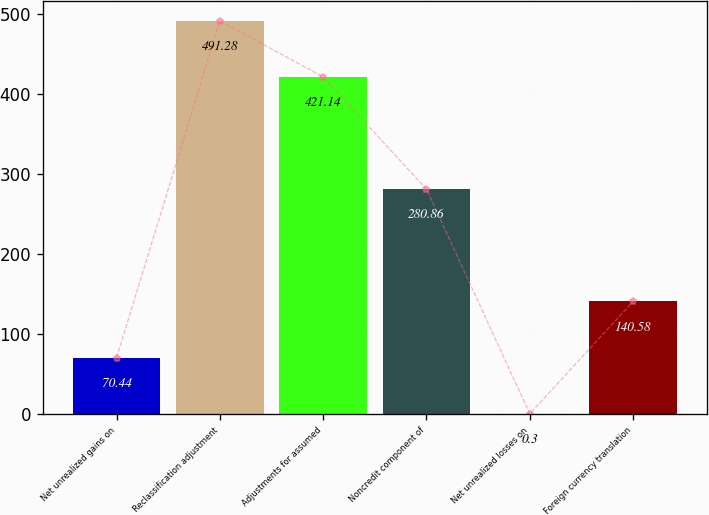Convert chart. <chart><loc_0><loc_0><loc_500><loc_500><bar_chart><fcel>Net unrealized gains on<fcel>Reclassification adjustment<fcel>Adjustments for assumed<fcel>Noncredit component of<fcel>Net unrealized losses on<fcel>Foreign currency translation<nl><fcel>70.44<fcel>491.28<fcel>421.14<fcel>280.86<fcel>0.3<fcel>140.58<nl></chart> 